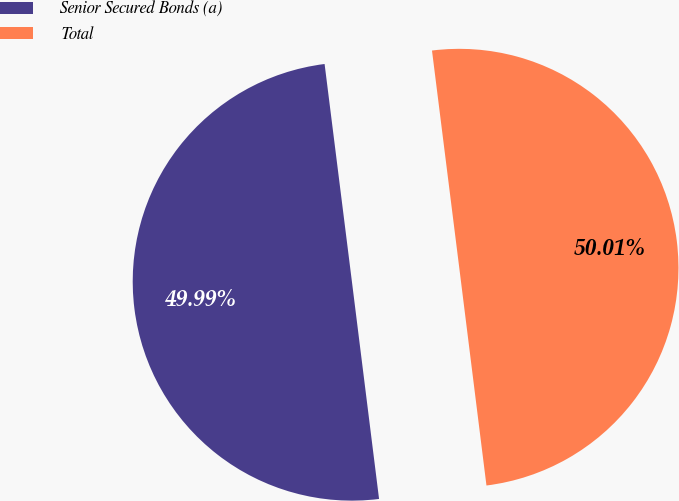Convert chart. <chart><loc_0><loc_0><loc_500><loc_500><pie_chart><fcel>Senior Secured Bonds (a)<fcel>Total<nl><fcel>49.99%<fcel>50.01%<nl></chart> 